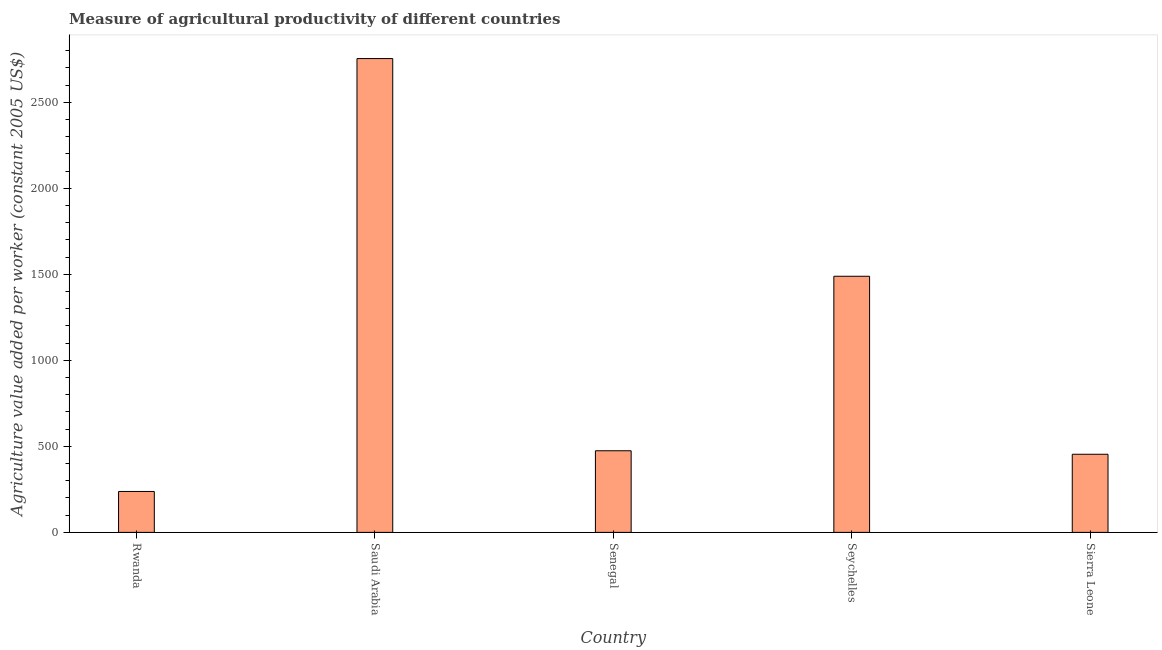Does the graph contain any zero values?
Your answer should be very brief. No. Does the graph contain grids?
Your answer should be very brief. No. What is the title of the graph?
Offer a very short reply. Measure of agricultural productivity of different countries. What is the label or title of the X-axis?
Give a very brief answer. Country. What is the label or title of the Y-axis?
Provide a succinct answer. Agriculture value added per worker (constant 2005 US$). What is the agriculture value added per worker in Senegal?
Keep it short and to the point. 474.51. Across all countries, what is the maximum agriculture value added per worker?
Offer a very short reply. 2754.3. Across all countries, what is the minimum agriculture value added per worker?
Your answer should be compact. 237.92. In which country was the agriculture value added per worker maximum?
Offer a very short reply. Saudi Arabia. In which country was the agriculture value added per worker minimum?
Keep it short and to the point. Rwanda. What is the sum of the agriculture value added per worker?
Provide a short and direct response. 5409.77. What is the difference between the agriculture value added per worker in Seychelles and Sierra Leone?
Provide a short and direct response. 1034.72. What is the average agriculture value added per worker per country?
Your answer should be very brief. 1081.95. What is the median agriculture value added per worker?
Keep it short and to the point. 474.51. In how many countries, is the agriculture value added per worker greater than 2000 US$?
Offer a very short reply. 1. What is the ratio of the agriculture value added per worker in Senegal to that in Seychelles?
Offer a terse response. 0.32. Is the difference between the agriculture value added per worker in Saudi Arabia and Sierra Leone greater than the difference between any two countries?
Your answer should be compact. No. What is the difference between the highest and the second highest agriculture value added per worker?
Provide a short and direct response. 1265.42. Is the sum of the agriculture value added per worker in Saudi Arabia and Sierra Leone greater than the maximum agriculture value added per worker across all countries?
Give a very brief answer. Yes. What is the difference between the highest and the lowest agriculture value added per worker?
Provide a short and direct response. 2516.38. Are all the bars in the graph horizontal?
Make the answer very short. No. How many countries are there in the graph?
Provide a short and direct response. 5. What is the difference between two consecutive major ticks on the Y-axis?
Ensure brevity in your answer.  500. Are the values on the major ticks of Y-axis written in scientific E-notation?
Your answer should be very brief. No. What is the Agriculture value added per worker (constant 2005 US$) in Rwanda?
Provide a succinct answer. 237.92. What is the Agriculture value added per worker (constant 2005 US$) of Saudi Arabia?
Provide a short and direct response. 2754.3. What is the Agriculture value added per worker (constant 2005 US$) in Senegal?
Provide a succinct answer. 474.51. What is the Agriculture value added per worker (constant 2005 US$) of Seychelles?
Offer a very short reply. 1488.88. What is the Agriculture value added per worker (constant 2005 US$) in Sierra Leone?
Your response must be concise. 454.16. What is the difference between the Agriculture value added per worker (constant 2005 US$) in Rwanda and Saudi Arabia?
Offer a very short reply. -2516.38. What is the difference between the Agriculture value added per worker (constant 2005 US$) in Rwanda and Senegal?
Provide a short and direct response. -236.59. What is the difference between the Agriculture value added per worker (constant 2005 US$) in Rwanda and Seychelles?
Offer a very short reply. -1250.96. What is the difference between the Agriculture value added per worker (constant 2005 US$) in Rwanda and Sierra Leone?
Offer a very short reply. -216.24. What is the difference between the Agriculture value added per worker (constant 2005 US$) in Saudi Arabia and Senegal?
Keep it short and to the point. 2279.8. What is the difference between the Agriculture value added per worker (constant 2005 US$) in Saudi Arabia and Seychelles?
Keep it short and to the point. 1265.42. What is the difference between the Agriculture value added per worker (constant 2005 US$) in Saudi Arabia and Sierra Leone?
Provide a short and direct response. 2300.14. What is the difference between the Agriculture value added per worker (constant 2005 US$) in Senegal and Seychelles?
Your answer should be compact. -1014.38. What is the difference between the Agriculture value added per worker (constant 2005 US$) in Senegal and Sierra Leone?
Provide a succinct answer. 20.35. What is the difference between the Agriculture value added per worker (constant 2005 US$) in Seychelles and Sierra Leone?
Your answer should be compact. 1034.72. What is the ratio of the Agriculture value added per worker (constant 2005 US$) in Rwanda to that in Saudi Arabia?
Make the answer very short. 0.09. What is the ratio of the Agriculture value added per worker (constant 2005 US$) in Rwanda to that in Senegal?
Your answer should be very brief. 0.5. What is the ratio of the Agriculture value added per worker (constant 2005 US$) in Rwanda to that in Seychelles?
Your answer should be very brief. 0.16. What is the ratio of the Agriculture value added per worker (constant 2005 US$) in Rwanda to that in Sierra Leone?
Provide a succinct answer. 0.52. What is the ratio of the Agriculture value added per worker (constant 2005 US$) in Saudi Arabia to that in Senegal?
Make the answer very short. 5.8. What is the ratio of the Agriculture value added per worker (constant 2005 US$) in Saudi Arabia to that in Seychelles?
Provide a short and direct response. 1.85. What is the ratio of the Agriculture value added per worker (constant 2005 US$) in Saudi Arabia to that in Sierra Leone?
Provide a succinct answer. 6.07. What is the ratio of the Agriculture value added per worker (constant 2005 US$) in Senegal to that in Seychelles?
Keep it short and to the point. 0.32. What is the ratio of the Agriculture value added per worker (constant 2005 US$) in Senegal to that in Sierra Leone?
Provide a succinct answer. 1.04. What is the ratio of the Agriculture value added per worker (constant 2005 US$) in Seychelles to that in Sierra Leone?
Make the answer very short. 3.28. 